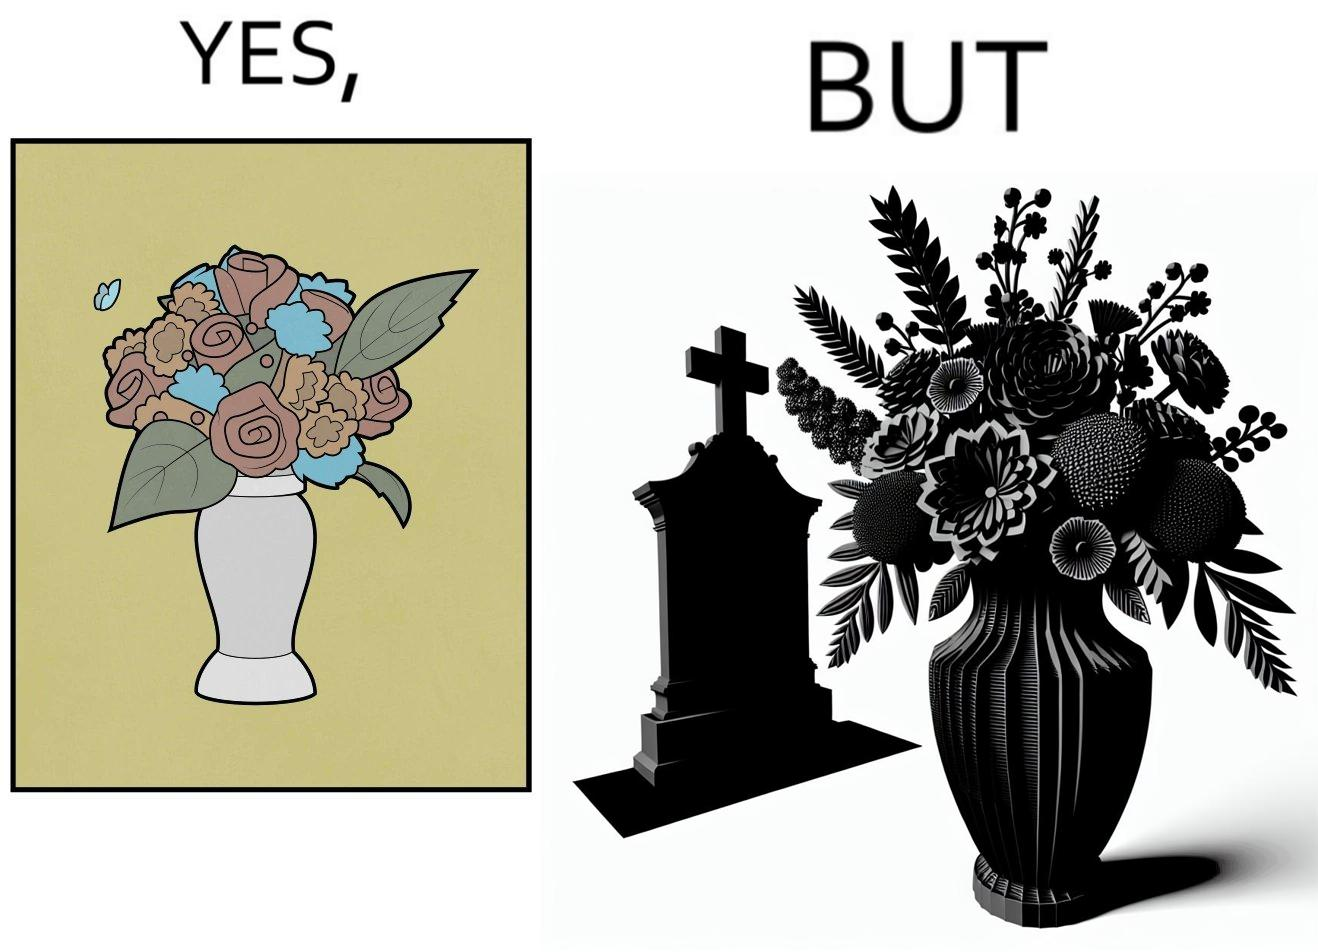What is shown in this image? The image is ironic, because in the first image a vase full of different beautiful flowers is seen which spreads a feeling of positivity, cheerfulness etc., whereas in the second image when the same vase is put in front of a grave stone it produces a feeling of sorrow 